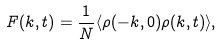<formula> <loc_0><loc_0><loc_500><loc_500>F ( k , t ) = \frac { 1 } { N } \langle \rho ( - k , 0 ) \rho ( k , t ) \rangle ,</formula> 